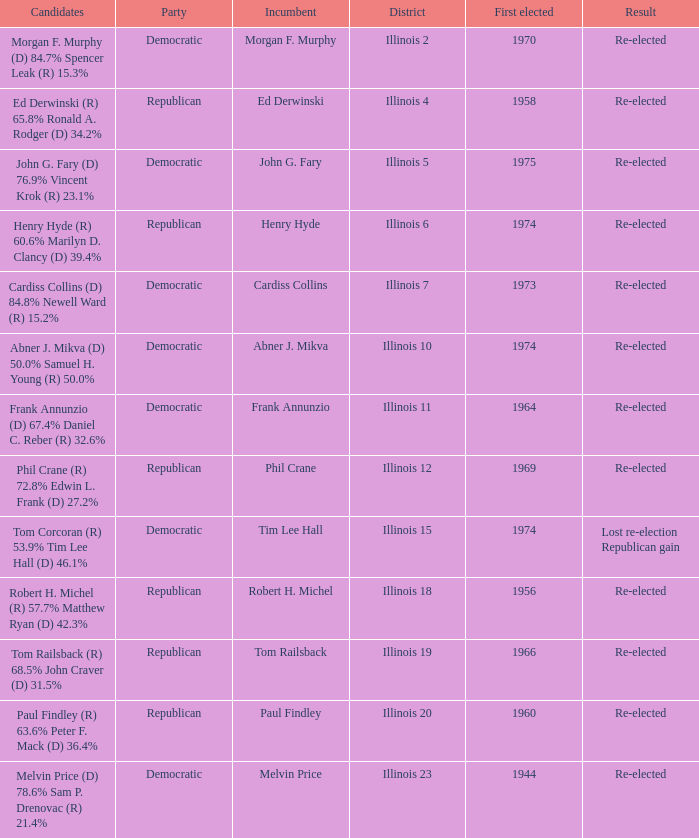Name the candidates for illinois 15 Tom Corcoran (R) 53.9% Tim Lee Hall (D) 46.1%. 